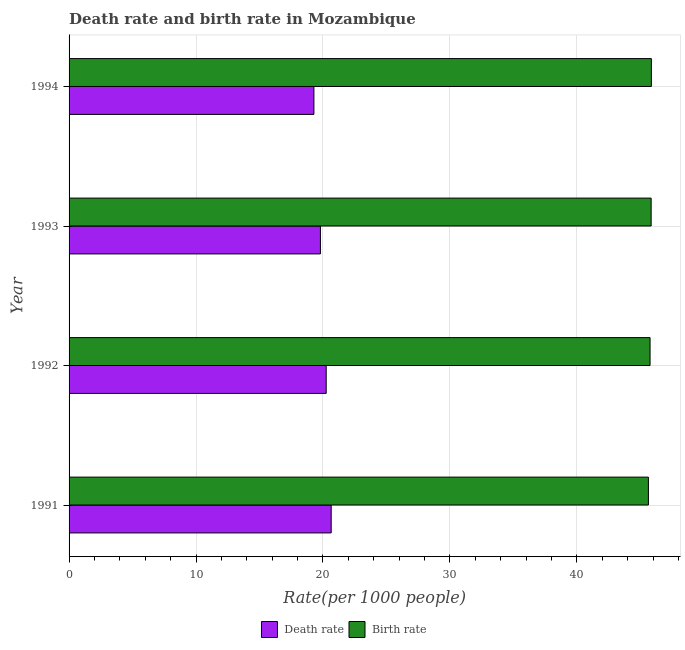How many different coloured bars are there?
Ensure brevity in your answer.  2. Are the number of bars on each tick of the Y-axis equal?
Provide a succinct answer. Yes. In how many cases, is the number of bars for a given year not equal to the number of legend labels?
Offer a terse response. 0. What is the birth rate in 1992?
Ensure brevity in your answer.  45.77. Across all years, what is the maximum death rate?
Keep it short and to the point. 20.65. Across all years, what is the minimum birth rate?
Keep it short and to the point. 45.64. In which year was the birth rate maximum?
Your answer should be compact. 1994. In which year was the birth rate minimum?
Your answer should be compact. 1991. What is the total death rate in the graph?
Offer a terse response. 79.99. What is the difference between the death rate in 1992 and that in 1994?
Offer a terse response. 0.97. What is the difference between the birth rate in 1992 and the death rate in 1994?
Provide a succinct answer. 26.48. What is the average death rate per year?
Keep it short and to the point. 20. In the year 1992, what is the difference between the death rate and birth rate?
Give a very brief answer. -25.51. What is the ratio of the birth rate in 1992 to that in 1994?
Make the answer very short. 1. Is the birth rate in 1991 less than that in 1992?
Ensure brevity in your answer.  Yes. Is the difference between the birth rate in 1991 and 1994 greater than the difference between the death rate in 1991 and 1994?
Make the answer very short. No. What is the difference between the highest and the second highest death rate?
Ensure brevity in your answer.  0.39. What is the difference between the highest and the lowest birth rate?
Offer a very short reply. 0.23. What does the 1st bar from the top in 1991 represents?
Make the answer very short. Birth rate. What does the 2nd bar from the bottom in 1994 represents?
Provide a short and direct response. Birth rate. Are all the bars in the graph horizontal?
Provide a succinct answer. Yes. Are the values on the major ticks of X-axis written in scientific E-notation?
Offer a terse response. No. Does the graph contain grids?
Give a very brief answer. Yes. What is the title of the graph?
Offer a terse response. Death rate and birth rate in Mozambique. Does "Female labor force" appear as one of the legend labels in the graph?
Your response must be concise. No. What is the label or title of the X-axis?
Offer a very short reply. Rate(per 1000 people). What is the label or title of the Y-axis?
Offer a very short reply. Year. What is the Rate(per 1000 people) in Death rate in 1991?
Keep it short and to the point. 20.65. What is the Rate(per 1000 people) of Birth rate in 1991?
Keep it short and to the point. 45.64. What is the Rate(per 1000 people) in Death rate in 1992?
Provide a short and direct response. 20.26. What is the Rate(per 1000 people) of Birth rate in 1992?
Ensure brevity in your answer.  45.77. What is the Rate(per 1000 people) of Death rate in 1993?
Your answer should be very brief. 19.8. What is the Rate(per 1000 people) of Birth rate in 1993?
Make the answer very short. 45.85. What is the Rate(per 1000 people) of Death rate in 1994?
Your answer should be very brief. 19.29. What is the Rate(per 1000 people) in Birth rate in 1994?
Provide a succinct answer. 45.87. Across all years, what is the maximum Rate(per 1000 people) in Death rate?
Make the answer very short. 20.65. Across all years, what is the maximum Rate(per 1000 people) in Birth rate?
Give a very brief answer. 45.87. Across all years, what is the minimum Rate(per 1000 people) in Death rate?
Ensure brevity in your answer.  19.29. Across all years, what is the minimum Rate(per 1000 people) in Birth rate?
Give a very brief answer. 45.64. What is the total Rate(per 1000 people) of Death rate in the graph?
Your response must be concise. 79.99. What is the total Rate(per 1000 people) of Birth rate in the graph?
Your response must be concise. 183.13. What is the difference between the Rate(per 1000 people) in Death rate in 1991 and that in 1992?
Keep it short and to the point. 0.39. What is the difference between the Rate(per 1000 people) of Birth rate in 1991 and that in 1992?
Make the answer very short. -0.13. What is the difference between the Rate(per 1000 people) of Death rate in 1991 and that in 1993?
Ensure brevity in your answer.  0.85. What is the difference between the Rate(per 1000 people) of Birth rate in 1991 and that in 1993?
Offer a very short reply. -0.21. What is the difference between the Rate(per 1000 people) of Death rate in 1991 and that in 1994?
Your answer should be compact. 1.36. What is the difference between the Rate(per 1000 people) in Birth rate in 1991 and that in 1994?
Ensure brevity in your answer.  -0.23. What is the difference between the Rate(per 1000 people) in Death rate in 1992 and that in 1993?
Offer a very short reply. 0.46. What is the difference between the Rate(per 1000 people) in Birth rate in 1992 and that in 1993?
Keep it short and to the point. -0.09. What is the difference between the Rate(per 1000 people) in Death rate in 1992 and that in 1994?
Your answer should be compact. 0.97. What is the difference between the Rate(per 1000 people) in Birth rate in 1992 and that in 1994?
Offer a very short reply. -0.1. What is the difference between the Rate(per 1000 people) of Death rate in 1993 and that in 1994?
Provide a short and direct response. 0.51. What is the difference between the Rate(per 1000 people) of Birth rate in 1993 and that in 1994?
Give a very brief answer. -0.02. What is the difference between the Rate(per 1000 people) of Death rate in 1991 and the Rate(per 1000 people) of Birth rate in 1992?
Ensure brevity in your answer.  -25.12. What is the difference between the Rate(per 1000 people) of Death rate in 1991 and the Rate(per 1000 people) of Birth rate in 1993?
Your response must be concise. -25.2. What is the difference between the Rate(per 1000 people) of Death rate in 1991 and the Rate(per 1000 people) of Birth rate in 1994?
Offer a terse response. -25.22. What is the difference between the Rate(per 1000 people) in Death rate in 1992 and the Rate(per 1000 people) in Birth rate in 1993?
Your answer should be very brief. -25.6. What is the difference between the Rate(per 1000 people) in Death rate in 1992 and the Rate(per 1000 people) in Birth rate in 1994?
Ensure brevity in your answer.  -25.62. What is the difference between the Rate(per 1000 people) in Death rate in 1993 and the Rate(per 1000 people) in Birth rate in 1994?
Give a very brief answer. -26.07. What is the average Rate(per 1000 people) of Death rate per year?
Make the answer very short. 20. What is the average Rate(per 1000 people) of Birth rate per year?
Keep it short and to the point. 45.78. In the year 1991, what is the difference between the Rate(per 1000 people) of Death rate and Rate(per 1000 people) of Birth rate?
Offer a very short reply. -24.99. In the year 1992, what is the difference between the Rate(per 1000 people) in Death rate and Rate(per 1000 people) in Birth rate?
Keep it short and to the point. -25.51. In the year 1993, what is the difference between the Rate(per 1000 people) in Death rate and Rate(per 1000 people) in Birth rate?
Your answer should be very brief. -26.05. In the year 1994, what is the difference between the Rate(per 1000 people) in Death rate and Rate(per 1000 people) in Birth rate?
Your answer should be very brief. -26.59. What is the ratio of the Rate(per 1000 people) in Death rate in 1991 to that in 1992?
Keep it short and to the point. 1.02. What is the ratio of the Rate(per 1000 people) in Birth rate in 1991 to that in 1992?
Your answer should be very brief. 1. What is the ratio of the Rate(per 1000 people) of Death rate in 1991 to that in 1993?
Offer a very short reply. 1.04. What is the ratio of the Rate(per 1000 people) in Death rate in 1991 to that in 1994?
Give a very brief answer. 1.07. What is the ratio of the Rate(per 1000 people) in Death rate in 1992 to that in 1993?
Ensure brevity in your answer.  1.02. What is the ratio of the Rate(per 1000 people) of Death rate in 1992 to that in 1994?
Offer a very short reply. 1.05. What is the ratio of the Rate(per 1000 people) in Birth rate in 1992 to that in 1994?
Ensure brevity in your answer.  1. What is the ratio of the Rate(per 1000 people) of Death rate in 1993 to that in 1994?
Your answer should be very brief. 1.03. What is the ratio of the Rate(per 1000 people) in Birth rate in 1993 to that in 1994?
Provide a succinct answer. 1. What is the difference between the highest and the second highest Rate(per 1000 people) in Death rate?
Provide a short and direct response. 0.39. What is the difference between the highest and the second highest Rate(per 1000 people) in Birth rate?
Your response must be concise. 0.02. What is the difference between the highest and the lowest Rate(per 1000 people) in Death rate?
Provide a short and direct response. 1.36. What is the difference between the highest and the lowest Rate(per 1000 people) of Birth rate?
Offer a terse response. 0.23. 